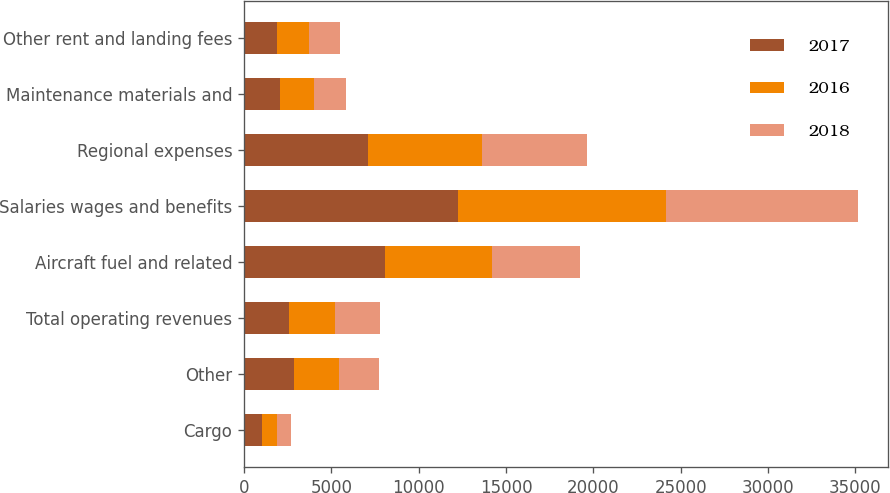Convert chart to OTSL. <chart><loc_0><loc_0><loc_500><loc_500><stacked_bar_chart><ecel><fcel>Cargo<fcel>Other<fcel>Total operating revenues<fcel>Aircraft fuel and related<fcel>Salaries wages and benefits<fcel>Regional expenses<fcel>Maintenance materials and<fcel>Other rent and landing fees<nl><fcel>2017<fcel>1013<fcel>2841<fcel>2589<fcel>8053<fcel>12240<fcel>7064<fcel>2050<fcel>1900<nl><fcel>2016<fcel>890<fcel>2589<fcel>2589<fcel>6128<fcel>11942<fcel>6572<fcel>1959<fcel>1806<nl><fcel>2018<fcel>785<fcel>2295<fcel>2589<fcel>5071<fcel>10958<fcel>6009<fcel>1834<fcel>1772<nl></chart> 